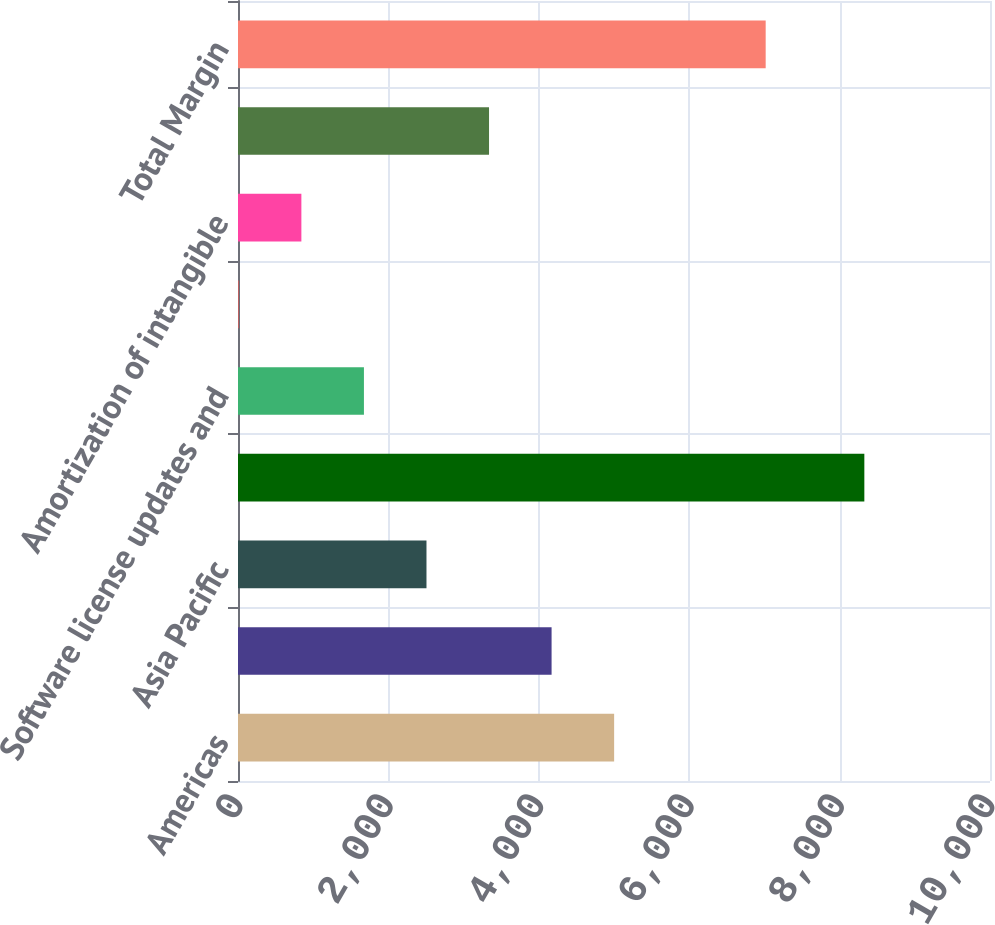<chart> <loc_0><loc_0><loc_500><loc_500><bar_chart><fcel>Americas<fcel>EMEA<fcel>Asia Pacific<fcel>Total revenues<fcel>Software license updates and<fcel>Stock-based compensation<fcel>Amortization of intangible<fcel>Total expenses<fcel>Total Margin<nl><fcel>5001.8<fcel>4170<fcel>2506.4<fcel>8329<fcel>1674.6<fcel>11<fcel>842.8<fcel>3338.2<fcel>7017<nl></chart> 